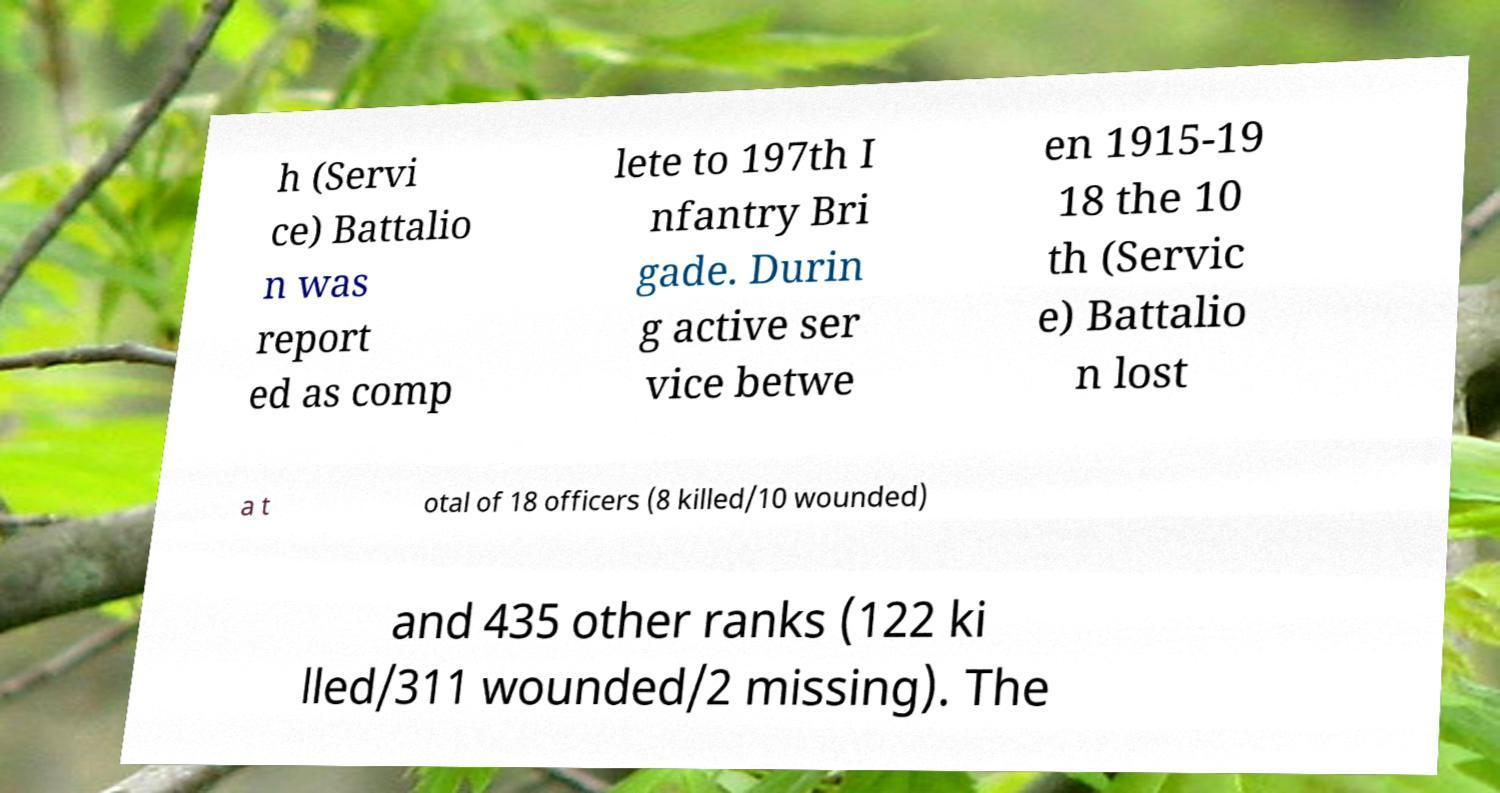There's text embedded in this image that I need extracted. Can you transcribe it verbatim? h (Servi ce) Battalio n was report ed as comp lete to 197th I nfantry Bri gade. Durin g active ser vice betwe en 1915-19 18 the 10 th (Servic e) Battalio n lost a t otal of 18 officers (8 killed/10 wounded) and 435 other ranks (122 ki lled/311 wounded/2 missing). The 